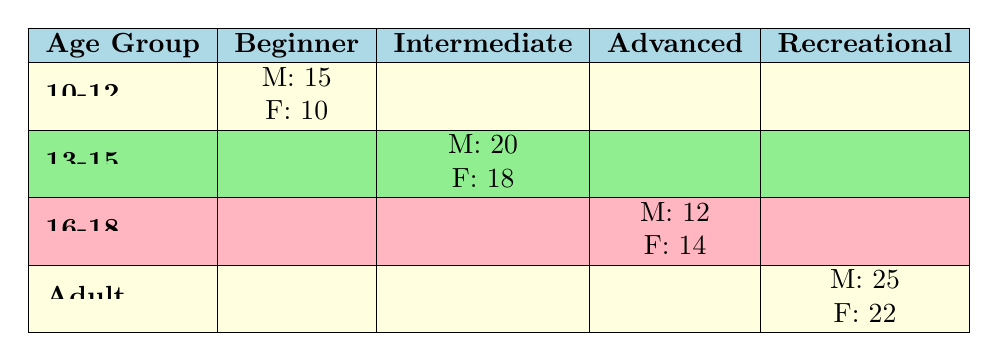What is the total number of male participants in the clinics? To find the total number of male participants, we sum the number of male participants across all age groups. The counts are: 15 (10-12) + 20 (13-15) + 12 (16-18) + 25 (Adult) = 72.
Answer: 72 What is the number of female participants in the 16-18 age group who are at an advanced skill level? The table shows 14 participants for females in the 16-18 age group at the advanced skill level. This can be directly retrieved from the table.
Answer: 14 Is there a higher number of male participants in the beginner skill level compared to female participants? For the beginner skill level, there are 15 male participants and 10 female participants. Since 15 is greater than 10, the answer is yes.
Answer: Yes What is the average number of participants per skill level for the adult age group? For the adult age group, there are 25 male participants in recreational skill level and 22 female participants, making a total of 25 + 22 = 47 participants. Since there is only one skill level (Recreational) in the adult age group, the average is simply 47/1 = 47.
Answer: 47 Which age group has the highest total number of participants, regardless of skill level or gender? We will calculate the total number of participants for each age group: 10-12: 15 + 10 = 25; 13-15: 20 + 18 = 38; 16-18: 12 + 14 = 26; Adult: 25 + 22 = 47. The highest total is 47 for the Adult age group.
Answer: Adult What percentage of the total participants are female in the 13-15 age group? The total number of participants in the 13-15 age group is 20 (male) + 18 (female) = 38. The number of female participants is 18. The percentage is (18/38) * 100 ≈ 47.37%.
Answer: Approximately 47.37% Are there more intermediate level participants than advanced level participants overall? We calculate the totals: Intermediate level has 20 (male) + 18 (female) = 38 participants; Advanced level has 12 (male) + 14 (female) = 26 participants. Since 38 is greater than 26, the answer is yes.
Answer: Yes What is the difference in the number of participants between the adult recreational level and the 10-12 beginner level? The adult recreational level has 25 (male) + 22 (female) = 47 participants. The 10-12 beginner level has 15 (male) + 10 (female) = 25 participants. The difference is 47 - 25 = 22.
Answer: 22 What fraction of male participants are in the adult age group? The total number of male participants is 72 (calculated previously). The number of male participants in the adult age group is 25. The fraction is 25/72.
Answer: 25/72 